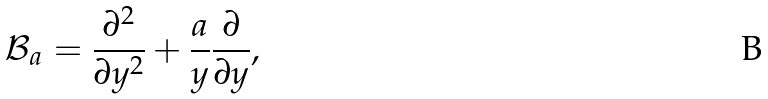<formula> <loc_0><loc_0><loc_500><loc_500>\mathcal { B } _ { a } = \frac { \partial ^ { 2 } } { \partial y ^ { 2 } } + \frac { a } { y } \frac { \partial } { \partial y } ,</formula> 